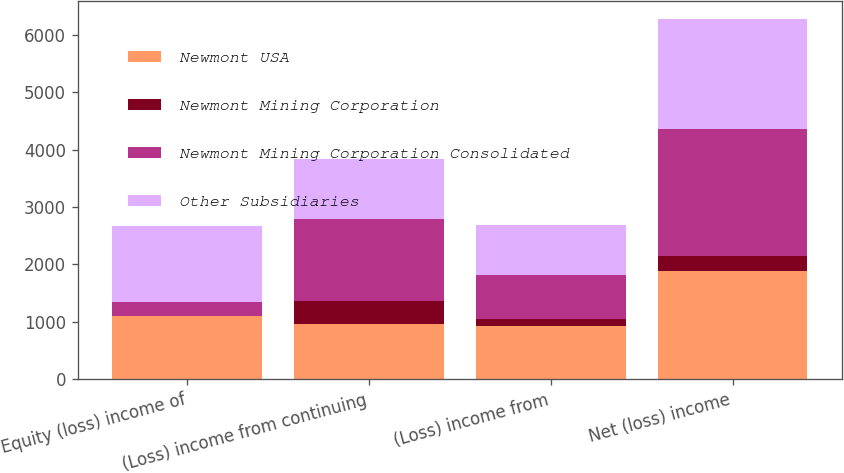<chart> <loc_0><loc_0><loc_500><loc_500><stacked_bar_chart><ecel><fcel>Equity (loss) income of<fcel>(Loss) income from continuing<fcel>(Loss) income from<fcel>Net (loss) income<nl><fcel>Newmont USA<fcel>1096<fcel>963<fcel>923<fcel>1886<nl><fcel>Newmont Mining Corporation<fcel>4<fcel>392<fcel>124<fcel>268<nl><fcel>Newmont Mining Corporation Consolidated<fcel>236<fcel>1439<fcel>760<fcel>2199<nl><fcel>Other Subsidiaries<fcel>1327<fcel>1047<fcel>884<fcel>1931<nl></chart> 